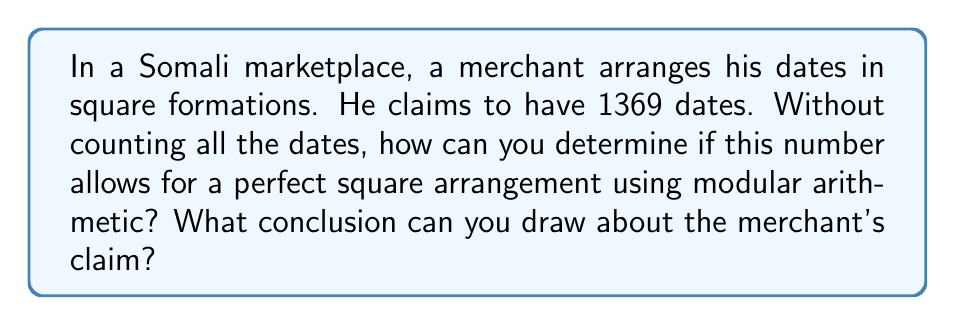Help me with this question. To determine if a number is a perfect square using modular arithmetic, we can use the following property:

If a number $n$ is a perfect square, then:
1. $n \equiv 0 \pmod{3}$ or $n \equiv 1 \pmod{3}$
2. $n \equiv 0 \pmod{4}$ or $n \equiv 1 \pmod{4}$

Let's apply this to 1369:

1. Check modulo 3:
   $1369 \div 3 = 456$ remainder $1$
   So, $1369 \equiv 1 \pmod{3}$
   This satisfies the first condition.

2. Check modulo 4:
   $1369 \div 4 = 342$ remainder $1$
   So, $1369 \equiv 1 \pmod{4}$
   This satisfies the second condition.

Since 1369 satisfies both conditions, it could be a perfect square. To verify, we can calculate its square root:

$$\sqrt{1369} = 37$$

Indeed, $37^2 = 1369$, confirming that 1369 is a perfect square.
Answer: Yes, 1369 is a perfect square. The merchant's claim about arranging the dates in a square formation is possible, as 1369 can be arranged in a 37 x 37 square. 